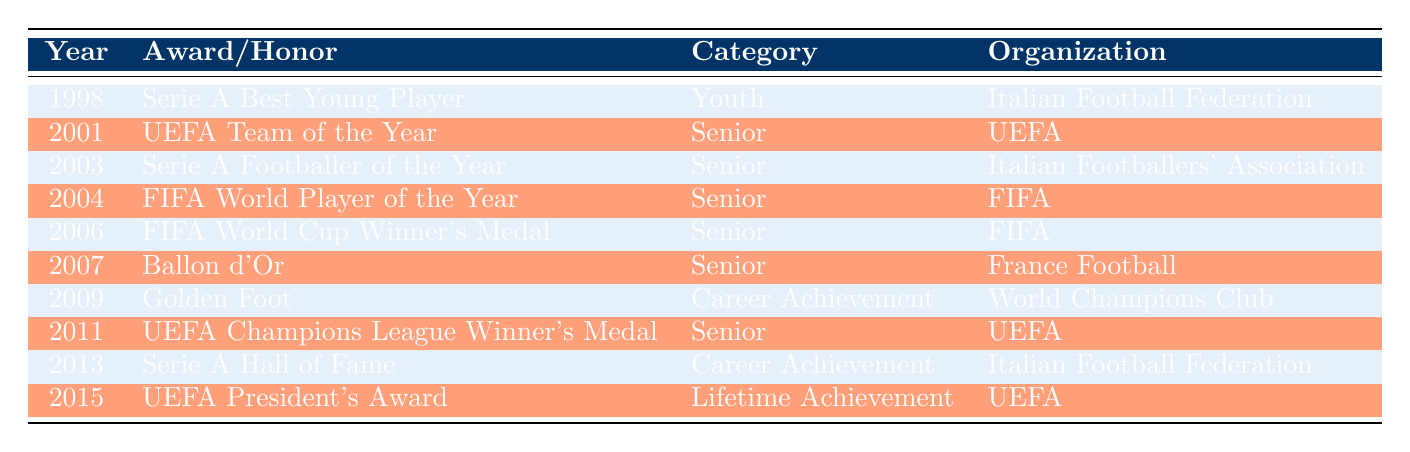What award did Baldi Rossi win in 2003? According to the table, Baldi Rossi won the "Serie A Footballer of the Year" award in 2003.
Answer: Serie A Footballer of the Year How many awards did Baldi Rossi receive in the "Senior" category? By examining the "Category" column, there are five instances labeled as "Senior": 2001 (UEFA Team of the Year), 2003 (Serie A Footballer of the Year), 2004 (FIFA World Player of the Year), 2006 (FIFA World Cup Winner's Medal), and 2007 (Ballon d'Or). Thus, there are five awards in the "Senior" category.
Answer: 5 Did Baldi Rossi receive any awards from the Italian Football Federation? The table shows that Baldi Rossi received the "Serie A Best Young Player" award in 1998 and was inducted into the "Serie A Hall of Fame" in 2013, both awarded by the Italian Football Federation. Therefore, the answer is yes.
Answer: Yes What is the total number of career achievement awards Baldi Rossi received? The table indicates two awards under the "Career Achievement" category: the "Golden Foot" in 2009 and "Serie A Hall of Fame" in 2013. Therefore, summing these gives a total of two career achievement awards.
Answer: 2 In which year did Baldi Rossi receive the Ballon d'Or? By checking the "Year" column, the Ballon d'Or award was received by Baldi Rossi in 2007.
Answer: 2007 What was the earliest award Baldi Rossi received according to the list? The earliest year listed in the table is 1998 when Baldi Rossi received the "Serie A Best Young Player" award.
Answer: 1998 How many awards does Baldi Rossi have that relate to lifetime achievement? The table lists one award in the "Lifetime Achievement" category: the "UEFA President's Award" in 2015. Hence, Baldi Rossi has one lifetime achievement award.
Answer: 1 Which organization awarded Baldi Rossi the "FIFA World Player of the Year"? The table specifies that the "FIFA World Player of the Year" award was given by FIFA in 2004.
Answer: FIFA Did Baldi Rossi win the UEFA Champions League Winner's Medal before he was inducted into the Serie A Hall of Fame? By examining the years, the "UEFA Champions League Winner's Medal" was awarded in 2011, while the "Serie A Hall of Fame" induction occurred in 2013. Thus, Baldi Rossi won the Champions League medal before the induction into the Hall of Fame.
Answer: Yes 